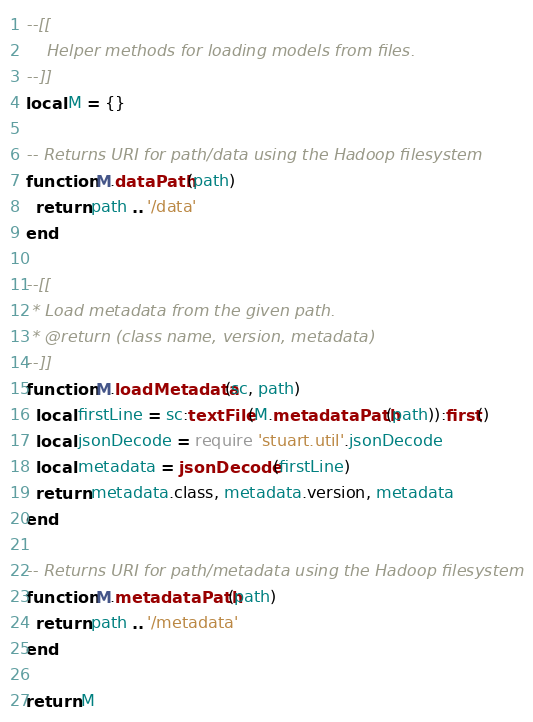<code> <loc_0><loc_0><loc_500><loc_500><_Lua_>--[[
    Helper methods for loading models from files.
--]]
local M = {}

-- Returns URI for path/data using the Hadoop filesystem
function M.dataPath(path)
  return path .. '/data'
end

--[[
 * Load metadata from the given path.
 * @return (class name, version, metadata)
--]]
function M.loadMetadata(sc, path)
  local firstLine = sc:textFile(M.metadataPath(path)):first()
  local jsonDecode = require 'stuart.util'.jsonDecode
  local metadata = jsonDecode(firstLine)
  return metadata.class, metadata.version, metadata
end

-- Returns URI for path/metadata using the Hadoop filesystem
function M.metadataPath(path)
  return path .. '/metadata'
end

return M
</code> 